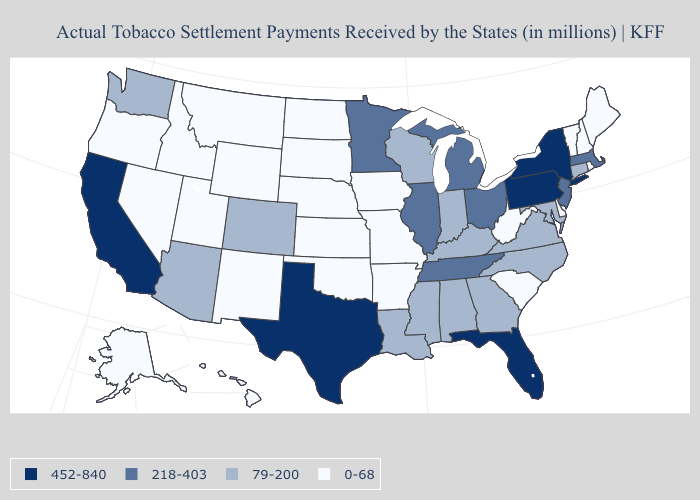Does South Dakota have a lower value than Virginia?
Write a very short answer. Yes. Which states have the lowest value in the USA?
Be succinct. Alaska, Arkansas, Delaware, Hawaii, Idaho, Iowa, Kansas, Maine, Missouri, Montana, Nebraska, Nevada, New Hampshire, New Mexico, North Dakota, Oklahoma, Oregon, Rhode Island, South Carolina, South Dakota, Utah, Vermont, West Virginia, Wyoming. Name the states that have a value in the range 218-403?
Concise answer only. Illinois, Massachusetts, Michigan, Minnesota, New Jersey, Ohio, Tennessee. Is the legend a continuous bar?
Keep it brief. No. What is the highest value in the USA?
Answer briefly. 452-840. Among the states that border Michigan , which have the highest value?
Keep it brief. Ohio. How many symbols are there in the legend?
Quick response, please. 4. Name the states that have a value in the range 0-68?
Quick response, please. Alaska, Arkansas, Delaware, Hawaii, Idaho, Iowa, Kansas, Maine, Missouri, Montana, Nebraska, Nevada, New Hampshire, New Mexico, North Dakota, Oklahoma, Oregon, Rhode Island, South Carolina, South Dakota, Utah, Vermont, West Virginia, Wyoming. How many symbols are there in the legend?
Short answer required. 4. Name the states that have a value in the range 0-68?
Answer briefly. Alaska, Arkansas, Delaware, Hawaii, Idaho, Iowa, Kansas, Maine, Missouri, Montana, Nebraska, Nevada, New Hampshire, New Mexico, North Dakota, Oklahoma, Oregon, Rhode Island, South Carolina, South Dakota, Utah, Vermont, West Virginia, Wyoming. Does New Jersey have the same value as Illinois?
Keep it brief. Yes. What is the lowest value in the USA?
Keep it brief. 0-68. 